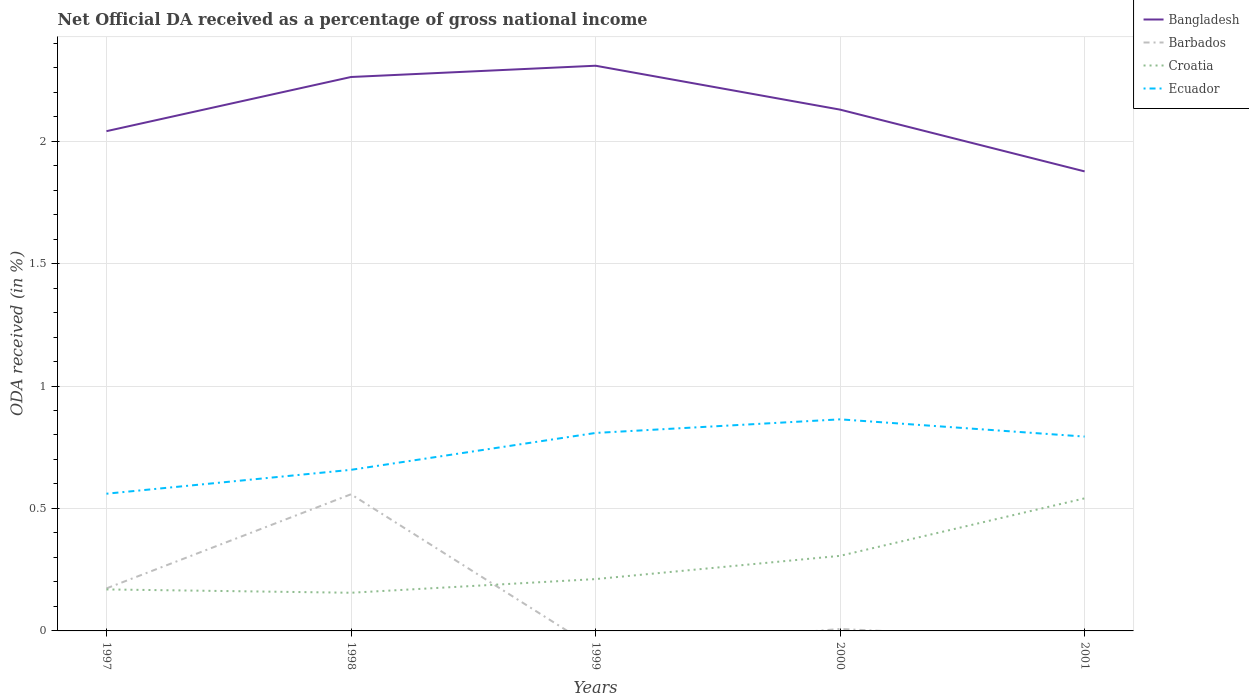Is the number of lines equal to the number of legend labels?
Offer a terse response. No. Across all years, what is the maximum net official DA received in Bangladesh?
Keep it short and to the point. 1.88. What is the total net official DA received in Croatia in the graph?
Your answer should be very brief. -0.33. What is the difference between the highest and the second highest net official DA received in Barbados?
Ensure brevity in your answer.  0.56. Are the values on the major ticks of Y-axis written in scientific E-notation?
Make the answer very short. No. Does the graph contain any zero values?
Your response must be concise. Yes. How many legend labels are there?
Your response must be concise. 4. How are the legend labels stacked?
Offer a terse response. Vertical. What is the title of the graph?
Provide a short and direct response. Net Official DA received as a percentage of gross national income. What is the label or title of the Y-axis?
Make the answer very short. ODA received (in %). What is the ODA received (in %) in Bangladesh in 1997?
Provide a succinct answer. 2.04. What is the ODA received (in %) in Barbados in 1997?
Your answer should be very brief. 0.17. What is the ODA received (in %) in Croatia in 1997?
Offer a very short reply. 0.17. What is the ODA received (in %) in Ecuador in 1997?
Give a very brief answer. 0.56. What is the ODA received (in %) in Bangladesh in 1998?
Make the answer very short. 2.26. What is the ODA received (in %) of Barbados in 1998?
Your response must be concise. 0.56. What is the ODA received (in %) in Croatia in 1998?
Your answer should be compact. 0.16. What is the ODA received (in %) of Ecuador in 1998?
Offer a terse response. 0.66. What is the ODA received (in %) of Bangladesh in 1999?
Your answer should be compact. 2.31. What is the ODA received (in %) in Barbados in 1999?
Offer a very short reply. 0. What is the ODA received (in %) of Croatia in 1999?
Provide a succinct answer. 0.21. What is the ODA received (in %) in Ecuador in 1999?
Provide a short and direct response. 0.81. What is the ODA received (in %) of Bangladesh in 2000?
Your answer should be compact. 2.13. What is the ODA received (in %) in Barbados in 2000?
Offer a terse response. 0.01. What is the ODA received (in %) in Croatia in 2000?
Offer a very short reply. 0.31. What is the ODA received (in %) of Ecuador in 2000?
Make the answer very short. 0.86. What is the ODA received (in %) in Bangladesh in 2001?
Keep it short and to the point. 1.88. What is the ODA received (in %) in Croatia in 2001?
Your answer should be very brief. 0.54. What is the ODA received (in %) in Ecuador in 2001?
Provide a succinct answer. 0.79. Across all years, what is the maximum ODA received (in %) of Bangladesh?
Make the answer very short. 2.31. Across all years, what is the maximum ODA received (in %) in Barbados?
Provide a short and direct response. 0.56. Across all years, what is the maximum ODA received (in %) in Croatia?
Offer a terse response. 0.54. Across all years, what is the maximum ODA received (in %) in Ecuador?
Make the answer very short. 0.86. Across all years, what is the minimum ODA received (in %) of Bangladesh?
Your answer should be very brief. 1.88. Across all years, what is the minimum ODA received (in %) in Barbados?
Offer a very short reply. 0. Across all years, what is the minimum ODA received (in %) in Croatia?
Keep it short and to the point. 0.16. Across all years, what is the minimum ODA received (in %) in Ecuador?
Your answer should be compact. 0.56. What is the total ODA received (in %) in Bangladesh in the graph?
Your answer should be compact. 10.61. What is the total ODA received (in %) in Barbados in the graph?
Your answer should be very brief. 0.74. What is the total ODA received (in %) of Croatia in the graph?
Make the answer very short. 1.38. What is the total ODA received (in %) of Ecuador in the graph?
Provide a short and direct response. 3.68. What is the difference between the ODA received (in %) in Bangladesh in 1997 and that in 1998?
Keep it short and to the point. -0.22. What is the difference between the ODA received (in %) in Barbados in 1997 and that in 1998?
Your response must be concise. -0.38. What is the difference between the ODA received (in %) in Croatia in 1997 and that in 1998?
Ensure brevity in your answer.  0.01. What is the difference between the ODA received (in %) of Ecuador in 1997 and that in 1998?
Give a very brief answer. -0.1. What is the difference between the ODA received (in %) of Bangladesh in 1997 and that in 1999?
Provide a short and direct response. -0.27. What is the difference between the ODA received (in %) in Croatia in 1997 and that in 1999?
Offer a very short reply. -0.04. What is the difference between the ODA received (in %) of Ecuador in 1997 and that in 1999?
Your response must be concise. -0.25. What is the difference between the ODA received (in %) in Bangladesh in 1997 and that in 2000?
Provide a short and direct response. -0.09. What is the difference between the ODA received (in %) of Barbados in 1997 and that in 2000?
Your response must be concise. 0.17. What is the difference between the ODA received (in %) of Croatia in 1997 and that in 2000?
Provide a short and direct response. -0.14. What is the difference between the ODA received (in %) of Ecuador in 1997 and that in 2000?
Give a very brief answer. -0.3. What is the difference between the ODA received (in %) of Bangladesh in 1997 and that in 2001?
Your response must be concise. 0.16. What is the difference between the ODA received (in %) in Croatia in 1997 and that in 2001?
Provide a succinct answer. -0.37. What is the difference between the ODA received (in %) in Ecuador in 1997 and that in 2001?
Provide a succinct answer. -0.23. What is the difference between the ODA received (in %) in Bangladesh in 1998 and that in 1999?
Ensure brevity in your answer.  -0.05. What is the difference between the ODA received (in %) in Croatia in 1998 and that in 1999?
Give a very brief answer. -0.06. What is the difference between the ODA received (in %) in Ecuador in 1998 and that in 1999?
Your response must be concise. -0.15. What is the difference between the ODA received (in %) in Bangladesh in 1998 and that in 2000?
Your answer should be very brief. 0.13. What is the difference between the ODA received (in %) of Barbados in 1998 and that in 2000?
Your response must be concise. 0.55. What is the difference between the ODA received (in %) of Croatia in 1998 and that in 2000?
Your answer should be compact. -0.15. What is the difference between the ODA received (in %) of Ecuador in 1998 and that in 2000?
Your answer should be very brief. -0.21. What is the difference between the ODA received (in %) in Bangladesh in 1998 and that in 2001?
Your response must be concise. 0.39. What is the difference between the ODA received (in %) in Croatia in 1998 and that in 2001?
Provide a succinct answer. -0.39. What is the difference between the ODA received (in %) in Ecuador in 1998 and that in 2001?
Ensure brevity in your answer.  -0.14. What is the difference between the ODA received (in %) of Bangladesh in 1999 and that in 2000?
Your answer should be very brief. 0.18. What is the difference between the ODA received (in %) of Croatia in 1999 and that in 2000?
Your answer should be very brief. -0.09. What is the difference between the ODA received (in %) in Ecuador in 1999 and that in 2000?
Provide a succinct answer. -0.06. What is the difference between the ODA received (in %) of Bangladesh in 1999 and that in 2001?
Offer a very short reply. 0.43. What is the difference between the ODA received (in %) in Croatia in 1999 and that in 2001?
Provide a short and direct response. -0.33. What is the difference between the ODA received (in %) of Ecuador in 1999 and that in 2001?
Provide a short and direct response. 0.01. What is the difference between the ODA received (in %) of Bangladesh in 2000 and that in 2001?
Offer a terse response. 0.25. What is the difference between the ODA received (in %) in Croatia in 2000 and that in 2001?
Your response must be concise. -0.23. What is the difference between the ODA received (in %) in Ecuador in 2000 and that in 2001?
Keep it short and to the point. 0.07. What is the difference between the ODA received (in %) of Bangladesh in 1997 and the ODA received (in %) of Barbados in 1998?
Give a very brief answer. 1.48. What is the difference between the ODA received (in %) of Bangladesh in 1997 and the ODA received (in %) of Croatia in 1998?
Make the answer very short. 1.88. What is the difference between the ODA received (in %) of Bangladesh in 1997 and the ODA received (in %) of Ecuador in 1998?
Provide a short and direct response. 1.38. What is the difference between the ODA received (in %) in Barbados in 1997 and the ODA received (in %) in Croatia in 1998?
Keep it short and to the point. 0.02. What is the difference between the ODA received (in %) of Barbados in 1997 and the ODA received (in %) of Ecuador in 1998?
Your answer should be very brief. -0.48. What is the difference between the ODA received (in %) in Croatia in 1997 and the ODA received (in %) in Ecuador in 1998?
Offer a very short reply. -0.49. What is the difference between the ODA received (in %) in Bangladesh in 1997 and the ODA received (in %) in Croatia in 1999?
Give a very brief answer. 1.83. What is the difference between the ODA received (in %) in Bangladesh in 1997 and the ODA received (in %) in Ecuador in 1999?
Give a very brief answer. 1.23. What is the difference between the ODA received (in %) in Barbados in 1997 and the ODA received (in %) in Croatia in 1999?
Give a very brief answer. -0.04. What is the difference between the ODA received (in %) of Barbados in 1997 and the ODA received (in %) of Ecuador in 1999?
Give a very brief answer. -0.63. What is the difference between the ODA received (in %) in Croatia in 1997 and the ODA received (in %) in Ecuador in 1999?
Offer a terse response. -0.64. What is the difference between the ODA received (in %) of Bangladesh in 1997 and the ODA received (in %) of Barbados in 2000?
Make the answer very short. 2.03. What is the difference between the ODA received (in %) in Bangladesh in 1997 and the ODA received (in %) in Croatia in 2000?
Ensure brevity in your answer.  1.73. What is the difference between the ODA received (in %) of Bangladesh in 1997 and the ODA received (in %) of Ecuador in 2000?
Your response must be concise. 1.18. What is the difference between the ODA received (in %) in Barbados in 1997 and the ODA received (in %) in Croatia in 2000?
Your answer should be very brief. -0.13. What is the difference between the ODA received (in %) in Barbados in 1997 and the ODA received (in %) in Ecuador in 2000?
Provide a succinct answer. -0.69. What is the difference between the ODA received (in %) of Croatia in 1997 and the ODA received (in %) of Ecuador in 2000?
Provide a succinct answer. -0.69. What is the difference between the ODA received (in %) in Bangladesh in 1997 and the ODA received (in %) in Croatia in 2001?
Offer a terse response. 1.5. What is the difference between the ODA received (in %) in Bangladesh in 1997 and the ODA received (in %) in Ecuador in 2001?
Your response must be concise. 1.25. What is the difference between the ODA received (in %) in Barbados in 1997 and the ODA received (in %) in Croatia in 2001?
Your answer should be very brief. -0.37. What is the difference between the ODA received (in %) of Barbados in 1997 and the ODA received (in %) of Ecuador in 2001?
Give a very brief answer. -0.62. What is the difference between the ODA received (in %) of Croatia in 1997 and the ODA received (in %) of Ecuador in 2001?
Offer a terse response. -0.62. What is the difference between the ODA received (in %) in Bangladesh in 1998 and the ODA received (in %) in Croatia in 1999?
Offer a terse response. 2.05. What is the difference between the ODA received (in %) in Bangladesh in 1998 and the ODA received (in %) in Ecuador in 1999?
Give a very brief answer. 1.45. What is the difference between the ODA received (in %) of Barbados in 1998 and the ODA received (in %) of Croatia in 1999?
Keep it short and to the point. 0.35. What is the difference between the ODA received (in %) in Barbados in 1998 and the ODA received (in %) in Ecuador in 1999?
Make the answer very short. -0.25. What is the difference between the ODA received (in %) in Croatia in 1998 and the ODA received (in %) in Ecuador in 1999?
Offer a terse response. -0.65. What is the difference between the ODA received (in %) of Bangladesh in 1998 and the ODA received (in %) of Barbados in 2000?
Give a very brief answer. 2.25. What is the difference between the ODA received (in %) in Bangladesh in 1998 and the ODA received (in %) in Croatia in 2000?
Your answer should be compact. 1.96. What is the difference between the ODA received (in %) in Bangladesh in 1998 and the ODA received (in %) in Ecuador in 2000?
Your answer should be very brief. 1.4. What is the difference between the ODA received (in %) in Barbados in 1998 and the ODA received (in %) in Croatia in 2000?
Give a very brief answer. 0.25. What is the difference between the ODA received (in %) of Barbados in 1998 and the ODA received (in %) of Ecuador in 2000?
Your response must be concise. -0.31. What is the difference between the ODA received (in %) of Croatia in 1998 and the ODA received (in %) of Ecuador in 2000?
Keep it short and to the point. -0.71. What is the difference between the ODA received (in %) of Bangladesh in 1998 and the ODA received (in %) of Croatia in 2001?
Your answer should be compact. 1.72. What is the difference between the ODA received (in %) in Bangladesh in 1998 and the ODA received (in %) in Ecuador in 2001?
Your answer should be very brief. 1.47. What is the difference between the ODA received (in %) in Barbados in 1998 and the ODA received (in %) in Croatia in 2001?
Your response must be concise. 0.02. What is the difference between the ODA received (in %) in Barbados in 1998 and the ODA received (in %) in Ecuador in 2001?
Offer a very short reply. -0.24. What is the difference between the ODA received (in %) in Croatia in 1998 and the ODA received (in %) in Ecuador in 2001?
Your response must be concise. -0.64. What is the difference between the ODA received (in %) in Bangladesh in 1999 and the ODA received (in %) in Barbados in 2000?
Offer a terse response. 2.3. What is the difference between the ODA received (in %) in Bangladesh in 1999 and the ODA received (in %) in Croatia in 2000?
Your answer should be compact. 2. What is the difference between the ODA received (in %) in Bangladesh in 1999 and the ODA received (in %) in Ecuador in 2000?
Your answer should be compact. 1.44. What is the difference between the ODA received (in %) of Croatia in 1999 and the ODA received (in %) of Ecuador in 2000?
Provide a short and direct response. -0.65. What is the difference between the ODA received (in %) in Bangladesh in 1999 and the ODA received (in %) in Croatia in 2001?
Your answer should be very brief. 1.77. What is the difference between the ODA received (in %) in Bangladesh in 1999 and the ODA received (in %) in Ecuador in 2001?
Offer a very short reply. 1.51. What is the difference between the ODA received (in %) of Croatia in 1999 and the ODA received (in %) of Ecuador in 2001?
Your answer should be very brief. -0.58. What is the difference between the ODA received (in %) in Bangladesh in 2000 and the ODA received (in %) in Croatia in 2001?
Ensure brevity in your answer.  1.59. What is the difference between the ODA received (in %) of Bangladesh in 2000 and the ODA received (in %) of Ecuador in 2001?
Your answer should be very brief. 1.33. What is the difference between the ODA received (in %) of Barbados in 2000 and the ODA received (in %) of Croatia in 2001?
Provide a short and direct response. -0.53. What is the difference between the ODA received (in %) in Barbados in 2000 and the ODA received (in %) in Ecuador in 2001?
Offer a very short reply. -0.79. What is the difference between the ODA received (in %) of Croatia in 2000 and the ODA received (in %) of Ecuador in 2001?
Keep it short and to the point. -0.49. What is the average ODA received (in %) in Bangladesh per year?
Give a very brief answer. 2.12. What is the average ODA received (in %) of Barbados per year?
Ensure brevity in your answer.  0.15. What is the average ODA received (in %) of Croatia per year?
Provide a short and direct response. 0.28. What is the average ODA received (in %) of Ecuador per year?
Keep it short and to the point. 0.74. In the year 1997, what is the difference between the ODA received (in %) in Bangladesh and ODA received (in %) in Barbados?
Offer a very short reply. 1.87. In the year 1997, what is the difference between the ODA received (in %) of Bangladesh and ODA received (in %) of Croatia?
Your answer should be compact. 1.87. In the year 1997, what is the difference between the ODA received (in %) of Bangladesh and ODA received (in %) of Ecuador?
Make the answer very short. 1.48. In the year 1997, what is the difference between the ODA received (in %) in Barbados and ODA received (in %) in Croatia?
Your answer should be compact. 0. In the year 1997, what is the difference between the ODA received (in %) in Barbados and ODA received (in %) in Ecuador?
Offer a terse response. -0.39. In the year 1997, what is the difference between the ODA received (in %) in Croatia and ODA received (in %) in Ecuador?
Ensure brevity in your answer.  -0.39. In the year 1998, what is the difference between the ODA received (in %) of Bangladesh and ODA received (in %) of Barbados?
Provide a short and direct response. 1.7. In the year 1998, what is the difference between the ODA received (in %) in Bangladesh and ODA received (in %) in Croatia?
Ensure brevity in your answer.  2.11. In the year 1998, what is the difference between the ODA received (in %) of Bangladesh and ODA received (in %) of Ecuador?
Offer a very short reply. 1.6. In the year 1998, what is the difference between the ODA received (in %) of Barbados and ODA received (in %) of Croatia?
Offer a very short reply. 0.4. In the year 1998, what is the difference between the ODA received (in %) of Barbados and ODA received (in %) of Ecuador?
Provide a short and direct response. -0.1. In the year 1998, what is the difference between the ODA received (in %) in Croatia and ODA received (in %) in Ecuador?
Your response must be concise. -0.5. In the year 1999, what is the difference between the ODA received (in %) in Bangladesh and ODA received (in %) in Croatia?
Give a very brief answer. 2.1. In the year 1999, what is the difference between the ODA received (in %) of Bangladesh and ODA received (in %) of Ecuador?
Ensure brevity in your answer.  1.5. In the year 1999, what is the difference between the ODA received (in %) in Croatia and ODA received (in %) in Ecuador?
Offer a very short reply. -0.6. In the year 2000, what is the difference between the ODA received (in %) of Bangladesh and ODA received (in %) of Barbados?
Your answer should be very brief. 2.12. In the year 2000, what is the difference between the ODA received (in %) in Bangladesh and ODA received (in %) in Croatia?
Your response must be concise. 1.82. In the year 2000, what is the difference between the ODA received (in %) in Bangladesh and ODA received (in %) in Ecuador?
Provide a short and direct response. 1.26. In the year 2000, what is the difference between the ODA received (in %) in Barbados and ODA received (in %) in Croatia?
Your response must be concise. -0.3. In the year 2000, what is the difference between the ODA received (in %) of Barbados and ODA received (in %) of Ecuador?
Give a very brief answer. -0.86. In the year 2000, what is the difference between the ODA received (in %) of Croatia and ODA received (in %) of Ecuador?
Your answer should be very brief. -0.56. In the year 2001, what is the difference between the ODA received (in %) in Bangladesh and ODA received (in %) in Croatia?
Your answer should be very brief. 1.33. In the year 2001, what is the difference between the ODA received (in %) of Bangladesh and ODA received (in %) of Ecuador?
Your response must be concise. 1.08. In the year 2001, what is the difference between the ODA received (in %) in Croatia and ODA received (in %) in Ecuador?
Your response must be concise. -0.25. What is the ratio of the ODA received (in %) in Bangladesh in 1997 to that in 1998?
Your answer should be compact. 0.9. What is the ratio of the ODA received (in %) of Barbados in 1997 to that in 1998?
Your answer should be compact. 0.31. What is the ratio of the ODA received (in %) of Croatia in 1997 to that in 1998?
Give a very brief answer. 1.09. What is the ratio of the ODA received (in %) of Ecuador in 1997 to that in 1998?
Offer a terse response. 0.85. What is the ratio of the ODA received (in %) in Bangladesh in 1997 to that in 1999?
Make the answer very short. 0.88. What is the ratio of the ODA received (in %) of Croatia in 1997 to that in 1999?
Your answer should be compact. 0.8. What is the ratio of the ODA received (in %) in Ecuador in 1997 to that in 1999?
Your answer should be very brief. 0.69. What is the ratio of the ODA received (in %) of Bangladesh in 1997 to that in 2000?
Your response must be concise. 0.96. What is the ratio of the ODA received (in %) in Barbados in 1997 to that in 2000?
Your answer should be compact. 21.88. What is the ratio of the ODA received (in %) in Croatia in 1997 to that in 2000?
Ensure brevity in your answer.  0.55. What is the ratio of the ODA received (in %) in Ecuador in 1997 to that in 2000?
Offer a very short reply. 0.65. What is the ratio of the ODA received (in %) in Bangladesh in 1997 to that in 2001?
Make the answer very short. 1.09. What is the ratio of the ODA received (in %) of Croatia in 1997 to that in 2001?
Give a very brief answer. 0.31. What is the ratio of the ODA received (in %) in Ecuador in 1997 to that in 2001?
Ensure brevity in your answer.  0.71. What is the ratio of the ODA received (in %) in Bangladesh in 1998 to that in 1999?
Your answer should be compact. 0.98. What is the ratio of the ODA received (in %) of Croatia in 1998 to that in 1999?
Make the answer very short. 0.74. What is the ratio of the ODA received (in %) of Ecuador in 1998 to that in 1999?
Keep it short and to the point. 0.81. What is the ratio of the ODA received (in %) in Bangladesh in 1998 to that in 2000?
Your answer should be compact. 1.06. What is the ratio of the ODA received (in %) in Barbados in 1998 to that in 2000?
Ensure brevity in your answer.  70.31. What is the ratio of the ODA received (in %) of Croatia in 1998 to that in 2000?
Ensure brevity in your answer.  0.51. What is the ratio of the ODA received (in %) of Ecuador in 1998 to that in 2000?
Provide a short and direct response. 0.76. What is the ratio of the ODA received (in %) in Bangladesh in 1998 to that in 2001?
Make the answer very short. 1.21. What is the ratio of the ODA received (in %) in Croatia in 1998 to that in 2001?
Provide a succinct answer. 0.29. What is the ratio of the ODA received (in %) in Ecuador in 1998 to that in 2001?
Your answer should be very brief. 0.83. What is the ratio of the ODA received (in %) in Bangladesh in 1999 to that in 2000?
Give a very brief answer. 1.08. What is the ratio of the ODA received (in %) in Croatia in 1999 to that in 2000?
Offer a terse response. 0.69. What is the ratio of the ODA received (in %) of Ecuador in 1999 to that in 2000?
Your answer should be very brief. 0.94. What is the ratio of the ODA received (in %) of Bangladesh in 1999 to that in 2001?
Your answer should be very brief. 1.23. What is the ratio of the ODA received (in %) of Croatia in 1999 to that in 2001?
Your answer should be compact. 0.39. What is the ratio of the ODA received (in %) of Ecuador in 1999 to that in 2001?
Your answer should be very brief. 1.02. What is the ratio of the ODA received (in %) in Bangladesh in 2000 to that in 2001?
Your answer should be very brief. 1.13. What is the ratio of the ODA received (in %) of Croatia in 2000 to that in 2001?
Provide a short and direct response. 0.57. What is the ratio of the ODA received (in %) of Ecuador in 2000 to that in 2001?
Keep it short and to the point. 1.09. What is the difference between the highest and the second highest ODA received (in %) of Bangladesh?
Give a very brief answer. 0.05. What is the difference between the highest and the second highest ODA received (in %) in Barbados?
Provide a succinct answer. 0.38. What is the difference between the highest and the second highest ODA received (in %) of Croatia?
Provide a short and direct response. 0.23. What is the difference between the highest and the second highest ODA received (in %) in Ecuador?
Keep it short and to the point. 0.06. What is the difference between the highest and the lowest ODA received (in %) of Bangladesh?
Your response must be concise. 0.43. What is the difference between the highest and the lowest ODA received (in %) of Barbados?
Offer a terse response. 0.56. What is the difference between the highest and the lowest ODA received (in %) of Croatia?
Provide a short and direct response. 0.39. What is the difference between the highest and the lowest ODA received (in %) in Ecuador?
Make the answer very short. 0.3. 